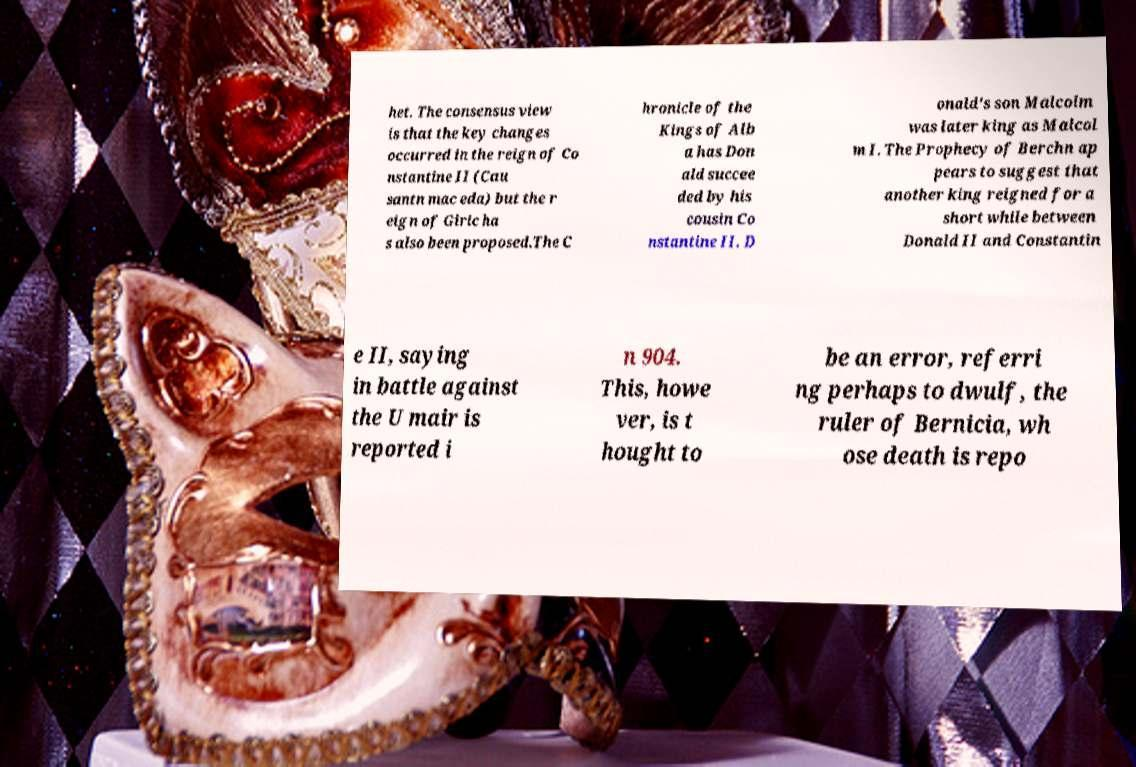Can you read and provide the text displayed in the image?This photo seems to have some interesting text. Can you extract and type it out for me? het. The consensus view is that the key changes occurred in the reign of Co nstantine II (Cau santn mac eda) but the r eign of Giric ha s also been proposed.The C hronicle of the Kings of Alb a has Don ald succee ded by his cousin Co nstantine II. D onald's son Malcolm was later king as Malcol m I. The Prophecy of Berchn ap pears to suggest that another king reigned for a short while between Donald II and Constantin e II, saying in battle against the U mair is reported i n 904. This, howe ver, is t hought to be an error, referri ng perhaps to dwulf, the ruler of Bernicia, wh ose death is repo 